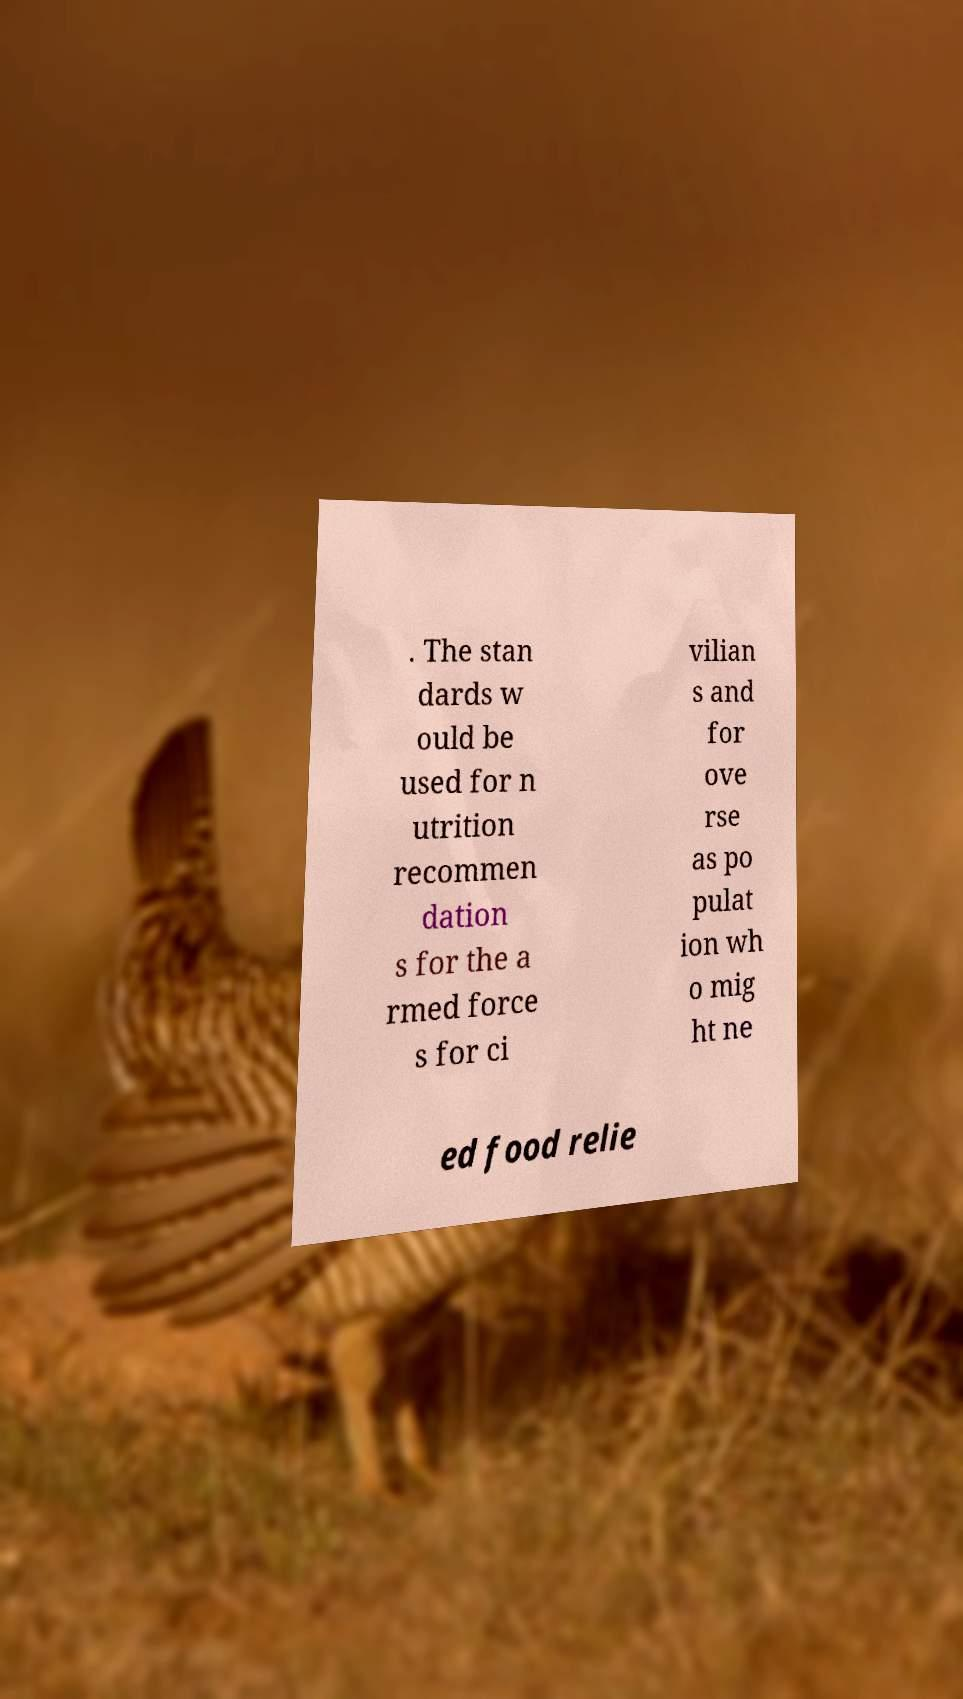Can you accurately transcribe the text from the provided image for me? . The stan dards w ould be used for n utrition recommen dation s for the a rmed force s for ci vilian s and for ove rse as po pulat ion wh o mig ht ne ed food relie 